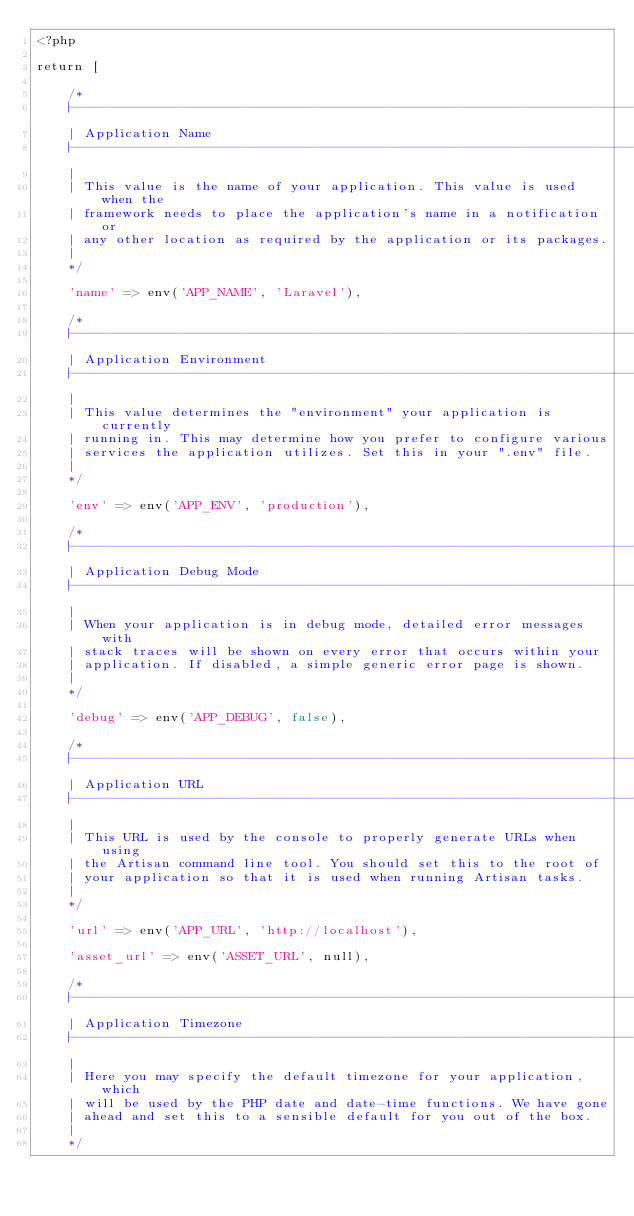<code> <loc_0><loc_0><loc_500><loc_500><_PHP_><?php

return [

    /*
    |--------------------------------------------------------------------------
    | Application Name
    |--------------------------------------------------------------------------
    |
    | This value is the name of your application. This value is used when the
    | framework needs to place the application's name in a notification or
    | any other location as required by the application or its packages.
    |
    */

    'name' => env('APP_NAME', 'Laravel'),

    /*
    |--------------------------------------------------------------------------
    | Application Environment
    |--------------------------------------------------------------------------
    |
    | This value determines the "environment" your application is currently
    | running in. This may determine how you prefer to configure various
    | services the application utilizes. Set this in your ".env" file.
    |
    */

    'env' => env('APP_ENV', 'production'),

    /*
    |--------------------------------------------------------------------------
    | Application Debug Mode
    |--------------------------------------------------------------------------
    |
    | When your application is in debug mode, detailed error messages with
    | stack traces will be shown on every error that occurs within your
    | application. If disabled, a simple generic error page is shown.
    |
    */

    'debug' => env('APP_DEBUG', false),

    /*
    |--------------------------------------------------------------------------
    | Application URL
    |--------------------------------------------------------------------------
    |
    | This URL is used by the console to properly generate URLs when using
    | the Artisan command line tool. You should set this to the root of
    | your application so that it is used when running Artisan tasks.
    |
    */

    'url' => env('APP_URL', 'http://localhost'),

    'asset_url' => env('ASSET_URL', null),

    /*
    |--------------------------------------------------------------------------
    | Application Timezone
    |--------------------------------------------------------------------------
    |
    | Here you may specify the default timezone for your application, which
    | will be used by the PHP date and date-time functions. We have gone
    | ahead and set this to a sensible default for you out of the box.
    |
    */
</code> 